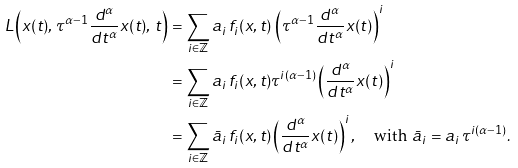<formula> <loc_0><loc_0><loc_500><loc_500>L \left ( x ( t ) , \, \tau ^ { \alpha - 1 } \frac { d ^ { \alpha } } { d t ^ { \alpha } } x ( t ) , \, t \right ) & = \sum _ { i \in \mathbb { Z } } a _ { i } \, f _ { i } ( x , t ) \, \left ( \tau ^ { \alpha - 1 } \frac { d ^ { \alpha } } { d t ^ { \alpha } } x ( t ) \right ) ^ { i } \\ & = \sum _ { i \in \mathbb { Z } } a _ { i } \, f _ { i } ( x , t ) \tau ^ { i ( \alpha - 1 ) } \left ( \frac { d ^ { \alpha } } { d t ^ { \alpha } } x ( t ) \right ) ^ { i } \\ & = \sum _ { i \in \mathbb { Z } } \bar { a } _ { i } \, f _ { i } ( x , t ) \left ( \frac { d ^ { \alpha } } { d t ^ { \alpha } } x ( t ) \right ) ^ { i } , \quad \text {with } \bar { a } _ { i } = a _ { i } \, \tau ^ { i ( \alpha - 1 ) } .</formula> 